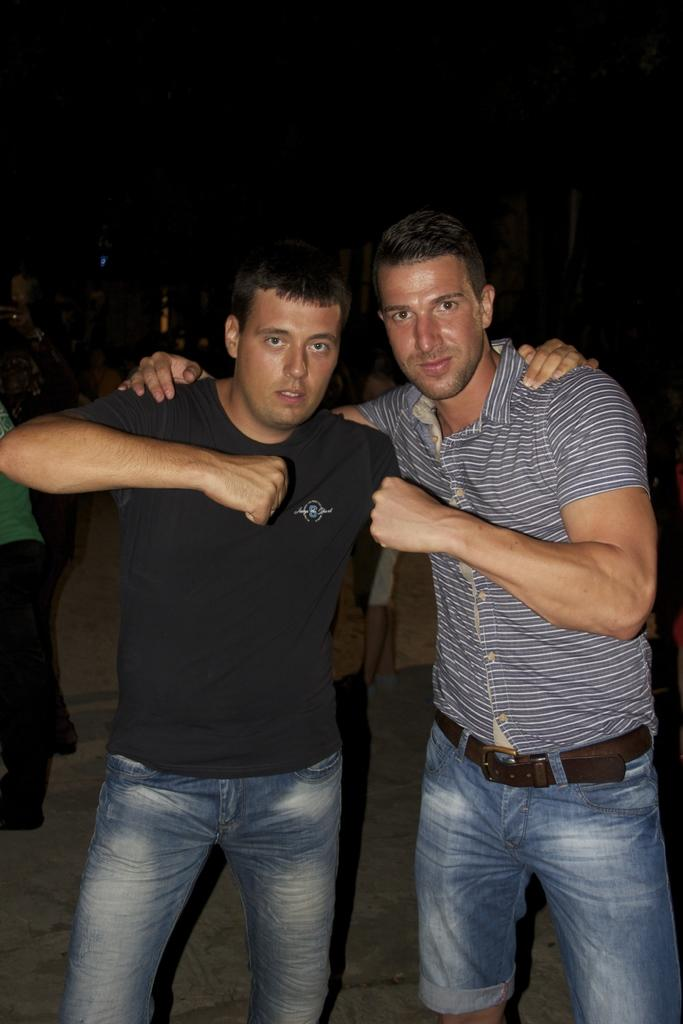How many men are visible in the image? There are two men standing in the image. What are the men doing in the image? The men are giving a pose for the picture. Can you describe the background of the image? The background appears to be dark. Are there any other people visible in the image besides the two men? Yes, there are more people standing in the background of the image. What type of curve can be seen in the hand of the man on the left? There is no curve visible in the hand of the man on the left, as the image does not show any details of their hands. 